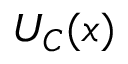Convert formula to latex. <formula><loc_0><loc_0><loc_500><loc_500>U _ { C } ( { x } )</formula> 